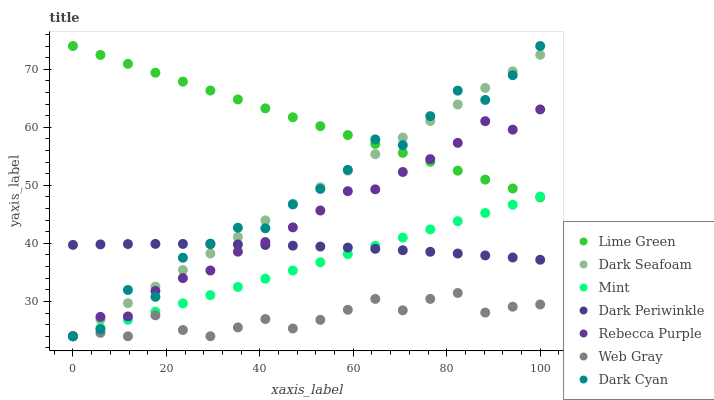Does Web Gray have the minimum area under the curve?
Answer yes or no. Yes. Does Lime Green have the maximum area under the curve?
Answer yes or no. Yes. Does Dark Seafoam have the minimum area under the curve?
Answer yes or no. No. Does Dark Seafoam have the maximum area under the curve?
Answer yes or no. No. Is Lime Green the smoothest?
Answer yes or no. Yes. Is Dark Cyan the roughest?
Answer yes or no. Yes. Is Dark Seafoam the smoothest?
Answer yes or no. No. Is Dark Seafoam the roughest?
Answer yes or no. No. Does Web Gray have the lowest value?
Answer yes or no. Yes. Does Lime Green have the lowest value?
Answer yes or no. No. Does Dark Cyan have the highest value?
Answer yes or no. Yes. Does Dark Seafoam have the highest value?
Answer yes or no. No. Is Web Gray less than Lime Green?
Answer yes or no. Yes. Is Lime Green greater than Dark Periwinkle?
Answer yes or no. Yes. Does Rebecca Purple intersect Dark Periwinkle?
Answer yes or no. Yes. Is Rebecca Purple less than Dark Periwinkle?
Answer yes or no. No. Is Rebecca Purple greater than Dark Periwinkle?
Answer yes or no. No. Does Web Gray intersect Lime Green?
Answer yes or no. No. 